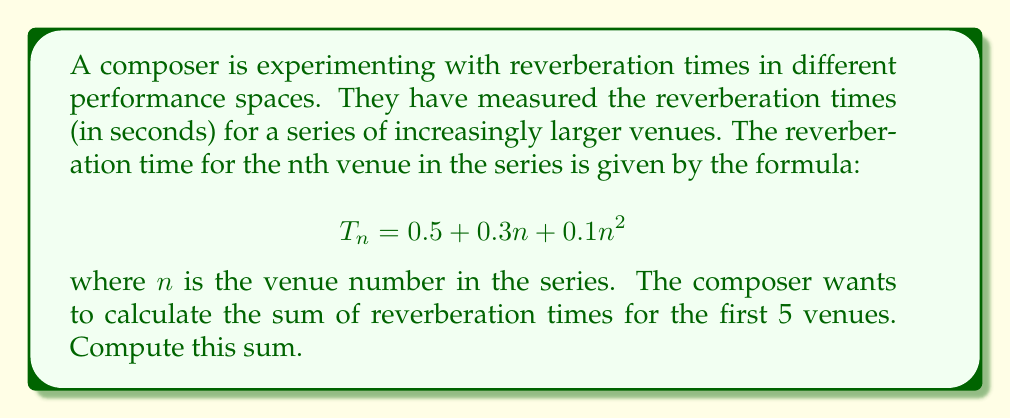Show me your answer to this math problem. To solve this problem, we need to calculate the reverberation time for each of the first 5 venues and then sum these values. Let's break it down step-by-step:

1) First, let's calculate $T_n$ for $n = 1$ to $5$:

   For $n = 1$: $T_1 = 0.5 + 0.3(1) + 0.1(1)^2 = 0.5 + 0.3 + 0.1 = 0.9$ seconds
   For $n = 2$: $T_2 = 0.5 + 0.3(2) + 0.1(2)^2 = 0.5 + 0.6 + 0.4 = 1.5$ seconds
   For $n = 3$: $T_3 = 0.5 + 0.3(3) + 0.1(3)^2 = 0.5 + 0.9 + 0.9 = 2.3$ seconds
   For $n = 4$: $T_4 = 0.5 + 0.3(4) + 0.1(4)^2 = 0.5 + 1.2 + 1.6 = 3.3$ seconds
   For $n = 5$: $T_5 = 0.5 + 0.3(5) + 0.1(5)^2 = 0.5 + 1.5 + 2.5 = 4.5$ seconds

2) Now, we need to sum these values:

   $$\sum_{n=1}^{5} T_n = T_1 + T_2 + T_3 + T_4 + T_5$$
   $$= 0.9 + 1.5 + 2.3 + 3.3 + 4.5$$
   $$= 12.5$$

Therefore, the sum of reverberation times for the first 5 venues is 12.5 seconds.
Answer: 12.5 seconds 